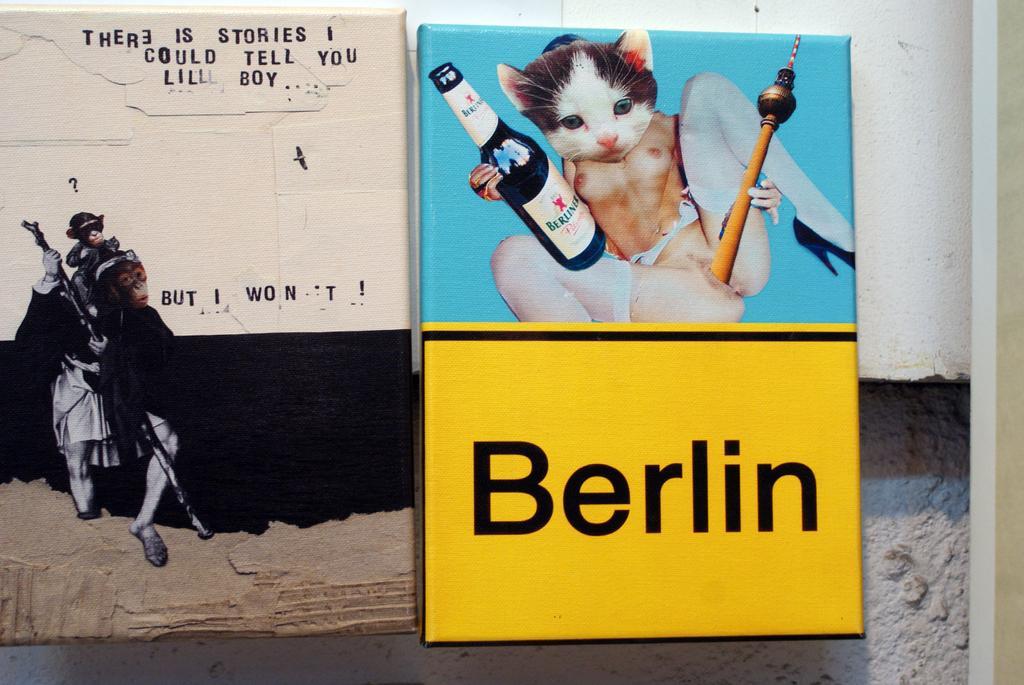Describe this image in one or two sentences. In the image there is a wall with painting and some text on it. And also there is a banner with an image and some text on it. 